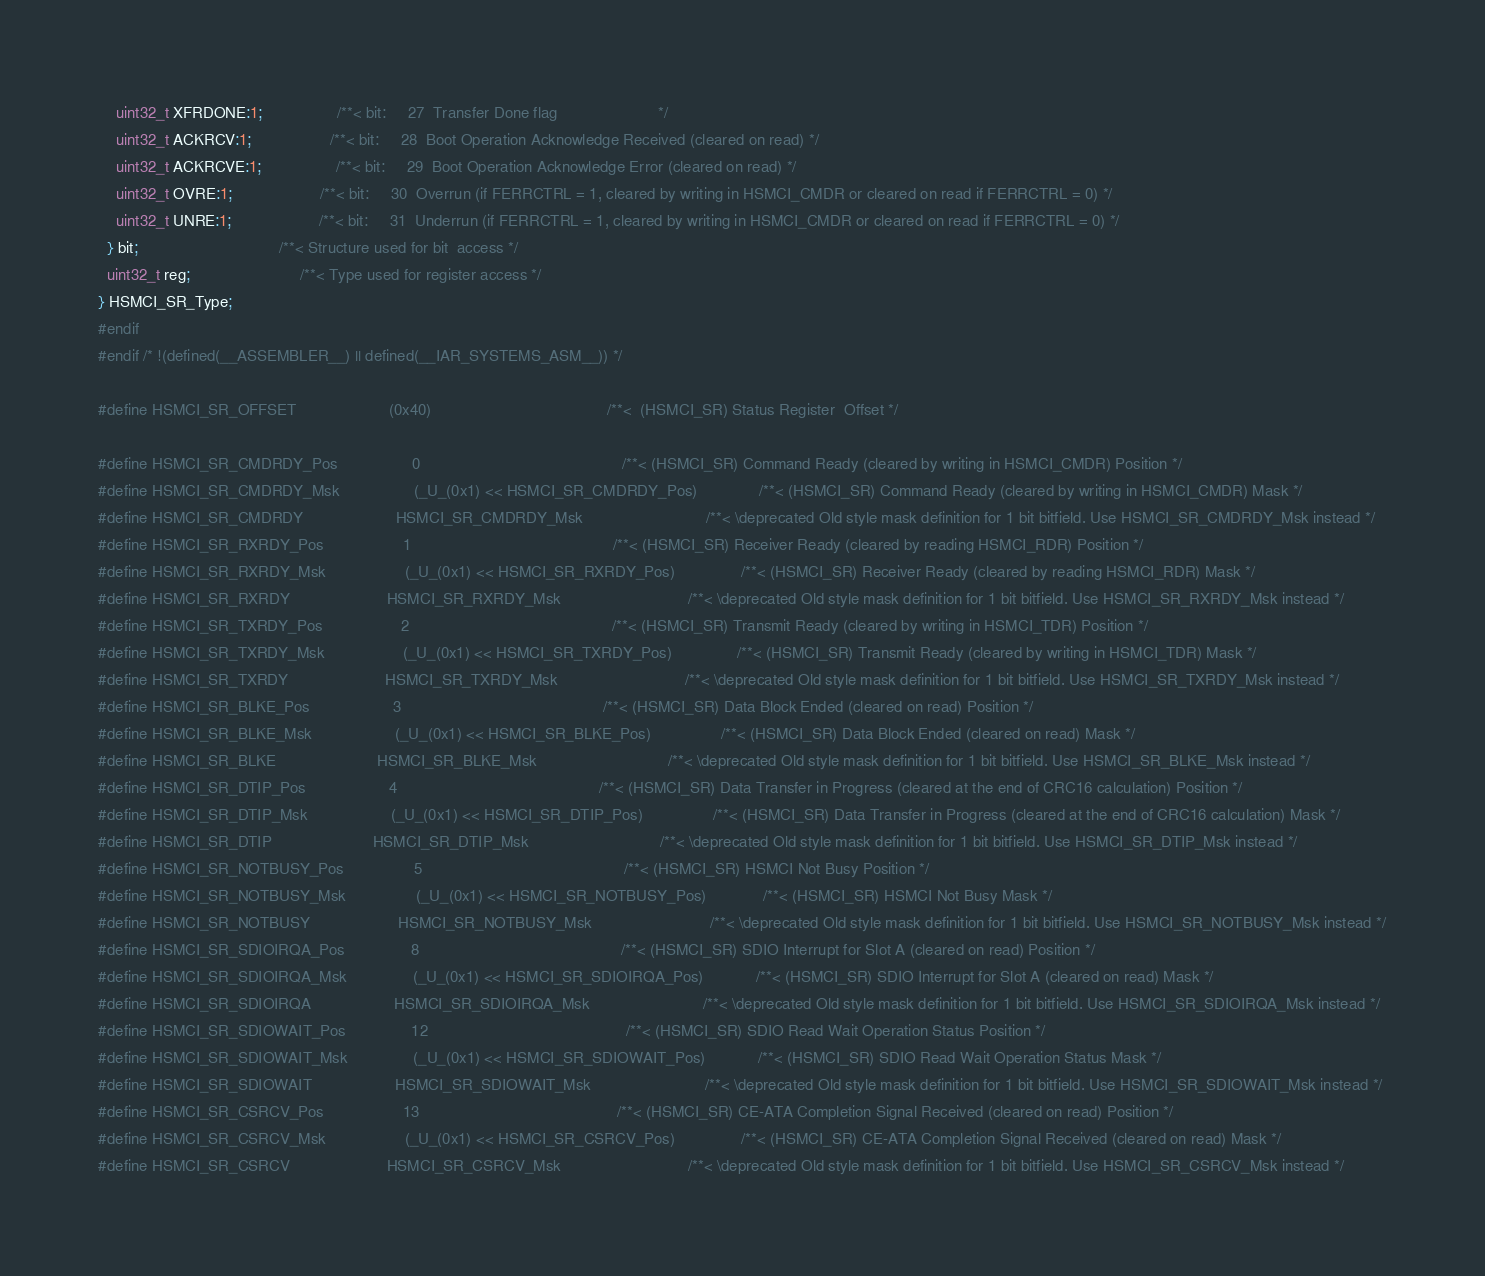Convert code to text. <code><loc_0><loc_0><loc_500><loc_500><_C_>    uint32_t XFRDONE:1;                 /**< bit:     27  Transfer Done flag                       */
    uint32_t ACKRCV:1;                  /**< bit:     28  Boot Operation Acknowledge Received (cleared on read) */
    uint32_t ACKRCVE:1;                 /**< bit:     29  Boot Operation Acknowledge Error (cleared on read) */
    uint32_t OVRE:1;                    /**< bit:     30  Overrun (if FERRCTRL = 1, cleared by writing in HSMCI_CMDR or cleared on read if FERRCTRL = 0) */
    uint32_t UNRE:1;                    /**< bit:     31  Underrun (if FERRCTRL = 1, cleared by writing in HSMCI_CMDR or cleared on read if FERRCTRL = 0) */
  } bit;                                /**< Structure used for bit  access */
  uint32_t reg;                         /**< Type used for register access */
} HSMCI_SR_Type;
#endif
#endif /* !(defined(__ASSEMBLER__) || defined(__IAR_SYSTEMS_ASM__)) */

#define HSMCI_SR_OFFSET                     (0x40)                                        /**<  (HSMCI_SR) Status Register  Offset */

#define HSMCI_SR_CMDRDY_Pos                 0                                              /**< (HSMCI_SR) Command Ready (cleared by writing in HSMCI_CMDR) Position */
#define HSMCI_SR_CMDRDY_Msk                 (_U_(0x1) << HSMCI_SR_CMDRDY_Pos)              /**< (HSMCI_SR) Command Ready (cleared by writing in HSMCI_CMDR) Mask */
#define HSMCI_SR_CMDRDY                     HSMCI_SR_CMDRDY_Msk                            /**< \deprecated Old style mask definition for 1 bit bitfield. Use HSMCI_SR_CMDRDY_Msk instead */
#define HSMCI_SR_RXRDY_Pos                  1                                              /**< (HSMCI_SR) Receiver Ready (cleared by reading HSMCI_RDR) Position */
#define HSMCI_SR_RXRDY_Msk                  (_U_(0x1) << HSMCI_SR_RXRDY_Pos)               /**< (HSMCI_SR) Receiver Ready (cleared by reading HSMCI_RDR) Mask */
#define HSMCI_SR_RXRDY                      HSMCI_SR_RXRDY_Msk                             /**< \deprecated Old style mask definition for 1 bit bitfield. Use HSMCI_SR_RXRDY_Msk instead */
#define HSMCI_SR_TXRDY_Pos                  2                                              /**< (HSMCI_SR) Transmit Ready (cleared by writing in HSMCI_TDR) Position */
#define HSMCI_SR_TXRDY_Msk                  (_U_(0x1) << HSMCI_SR_TXRDY_Pos)               /**< (HSMCI_SR) Transmit Ready (cleared by writing in HSMCI_TDR) Mask */
#define HSMCI_SR_TXRDY                      HSMCI_SR_TXRDY_Msk                             /**< \deprecated Old style mask definition for 1 bit bitfield. Use HSMCI_SR_TXRDY_Msk instead */
#define HSMCI_SR_BLKE_Pos                   3                                              /**< (HSMCI_SR) Data Block Ended (cleared on read) Position */
#define HSMCI_SR_BLKE_Msk                   (_U_(0x1) << HSMCI_SR_BLKE_Pos)                /**< (HSMCI_SR) Data Block Ended (cleared on read) Mask */
#define HSMCI_SR_BLKE                       HSMCI_SR_BLKE_Msk                              /**< \deprecated Old style mask definition for 1 bit bitfield. Use HSMCI_SR_BLKE_Msk instead */
#define HSMCI_SR_DTIP_Pos                   4                                              /**< (HSMCI_SR) Data Transfer in Progress (cleared at the end of CRC16 calculation) Position */
#define HSMCI_SR_DTIP_Msk                   (_U_(0x1) << HSMCI_SR_DTIP_Pos)                /**< (HSMCI_SR) Data Transfer in Progress (cleared at the end of CRC16 calculation) Mask */
#define HSMCI_SR_DTIP                       HSMCI_SR_DTIP_Msk                              /**< \deprecated Old style mask definition for 1 bit bitfield. Use HSMCI_SR_DTIP_Msk instead */
#define HSMCI_SR_NOTBUSY_Pos                5                                              /**< (HSMCI_SR) HSMCI Not Busy Position */
#define HSMCI_SR_NOTBUSY_Msk                (_U_(0x1) << HSMCI_SR_NOTBUSY_Pos)             /**< (HSMCI_SR) HSMCI Not Busy Mask */
#define HSMCI_SR_NOTBUSY                    HSMCI_SR_NOTBUSY_Msk                           /**< \deprecated Old style mask definition for 1 bit bitfield. Use HSMCI_SR_NOTBUSY_Msk instead */
#define HSMCI_SR_SDIOIRQA_Pos               8                                              /**< (HSMCI_SR) SDIO Interrupt for Slot A (cleared on read) Position */
#define HSMCI_SR_SDIOIRQA_Msk               (_U_(0x1) << HSMCI_SR_SDIOIRQA_Pos)            /**< (HSMCI_SR) SDIO Interrupt for Slot A (cleared on read) Mask */
#define HSMCI_SR_SDIOIRQA                   HSMCI_SR_SDIOIRQA_Msk                          /**< \deprecated Old style mask definition for 1 bit bitfield. Use HSMCI_SR_SDIOIRQA_Msk instead */
#define HSMCI_SR_SDIOWAIT_Pos               12                                             /**< (HSMCI_SR) SDIO Read Wait Operation Status Position */
#define HSMCI_SR_SDIOWAIT_Msk               (_U_(0x1) << HSMCI_SR_SDIOWAIT_Pos)            /**< (HSMCI_SR) SDIO Read Wait Operation Status Mask */
#define HSMCI_SR_SDIOWAIT                   HSMCI_SR_SDIOWAIT_Msk                          /**< \deprecated Old style mask definition for 1 bit bitfield. Use HSMCI_SR_SDIOWAIT_Msk instead */
#define HSMCI_SR_CSRCV_Pos                  13                                             /**< (HSMCI_SR) CE-ATA Completion Signal Received (cleared on read) Position */
#define HSMCI_SR_CSRCV_Msk                  (_U_(0x1) << HSMCI_SR_CSRCV_Pos)               /**< (HSMCI_SR) CE-ATA Completion Signal Received (cleared on read) Mask */
#define HSMCI_SR_CSRCV                      HSMCI_SR_CSRCV_Msk                             /**< \deprecated Old style mask definition for 1 bit bitfield. Use HSMCI_SR_CSRCV_Msk instead */</code> 